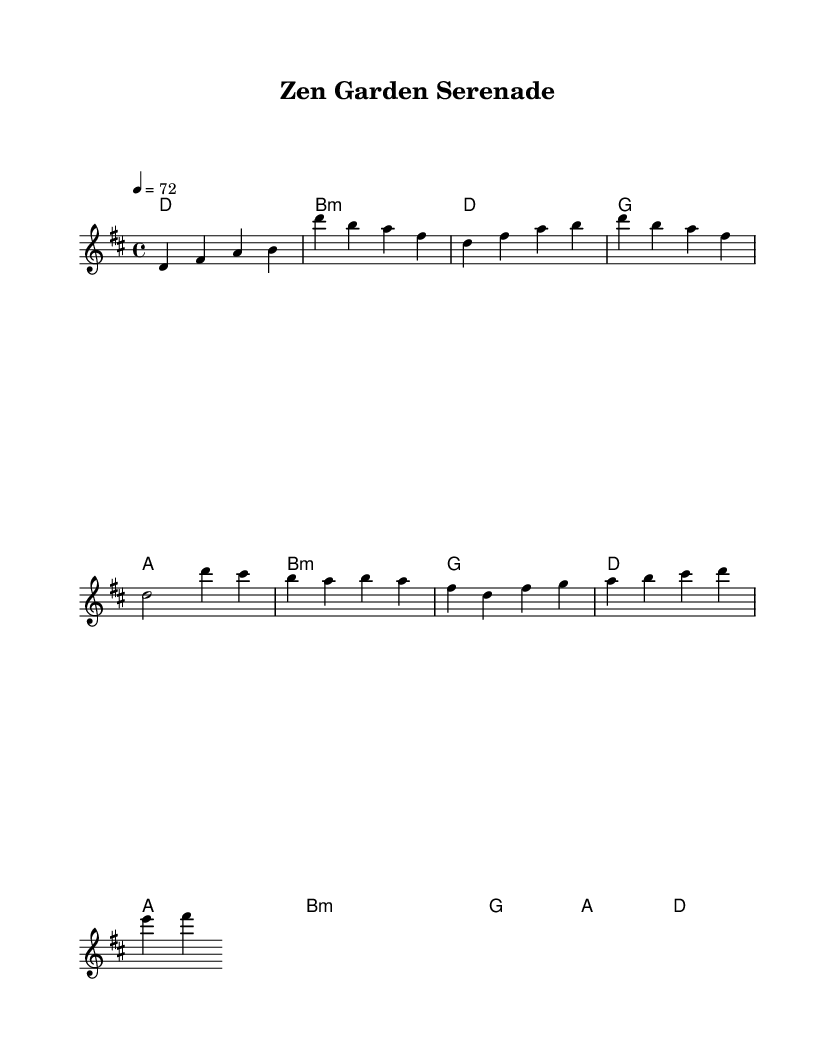What is the key signature of this music? The key signature is D major, which has two sharps (F# and C#). This is determined by looking at the notes and identifying the key signature in the sheet music.
Answer: D major What is the time signature of this music? The time signature is 4/4, indicated at the beginning of the score. This means there are four beats in a measure and a quarter note gets one beat.
Answer: 4/4 What is the tempo marking for this piece? The tempo marking is 72, indicated as "4 = 72". This means there are 72 beats per minute, and quarter notes are to be counted at this speed.
Answer: 72 What is the first chord in the intro? The first chord in the intro is D major, which is shown in the chord symbols above the melody.
Answer: D How many measures are in the verse section? There are four measures in the verse section as observed from the notation that outlines this section. Each measure is separated by vertical lines.
Answer: 4 What is the last chord of the bridge? The last chord of the bridge is D major, indicated in the chord symbols for that section of the music.
Answer: D Which section contains the chorus? The chorus section is located right after the verse and is characterized by the specific notes that differ from the verse. It can be identified by its distinct melodic and harmonic differences.
Answer: Chorus 